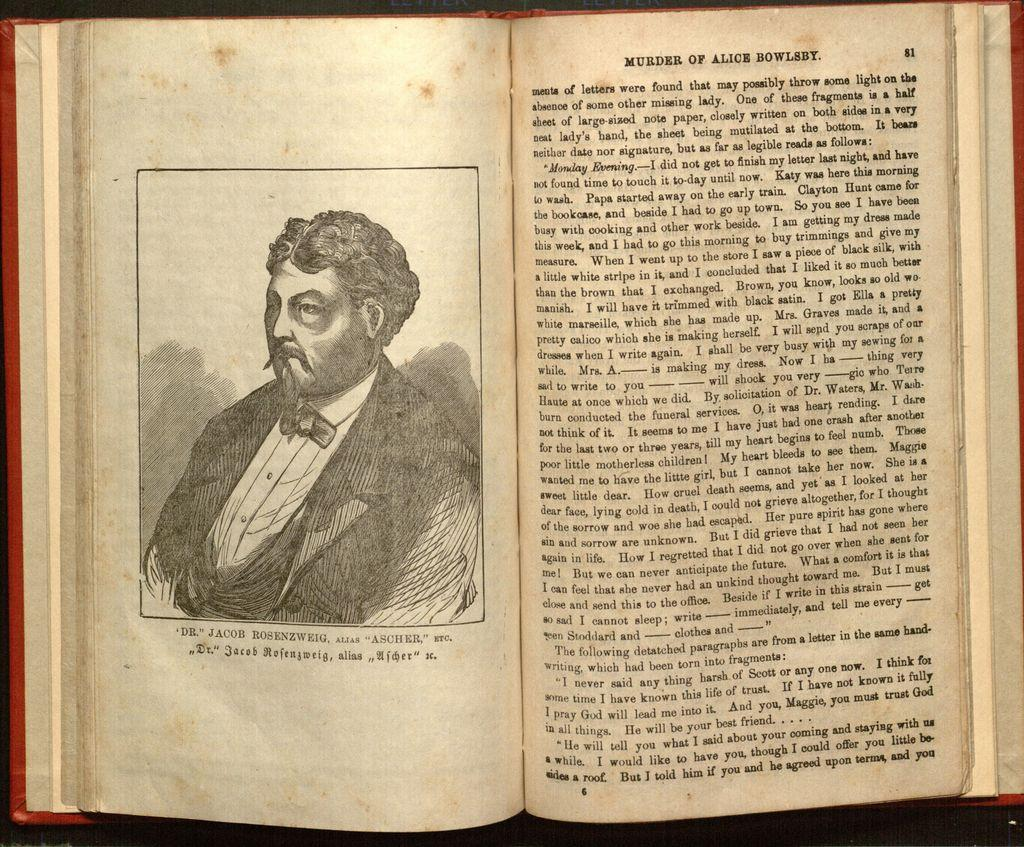<image>
Describe the image concisely. an open book to page 81 titled murder of alice bowlsby 